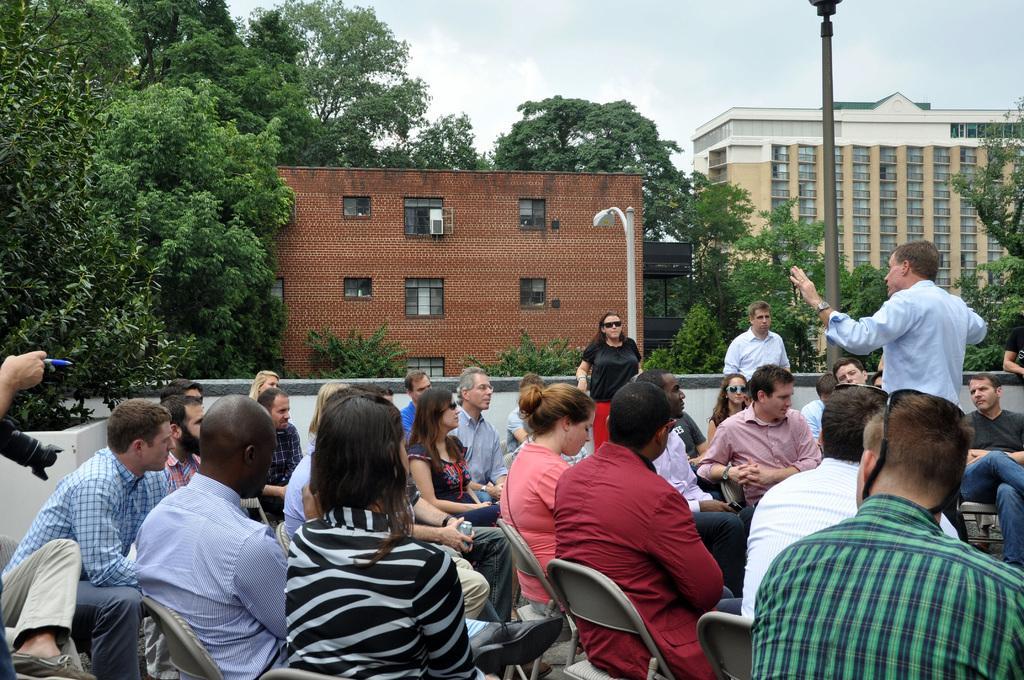Describe this image in one or two sentences. In this image I can see number of people where few are standing and rest all are sitting on chairs. On the left side of the image I can see one of them is holding a pen and a camera. In the background I can see two poles, two lights, few buildings, number of trees, clouds and the sky. 